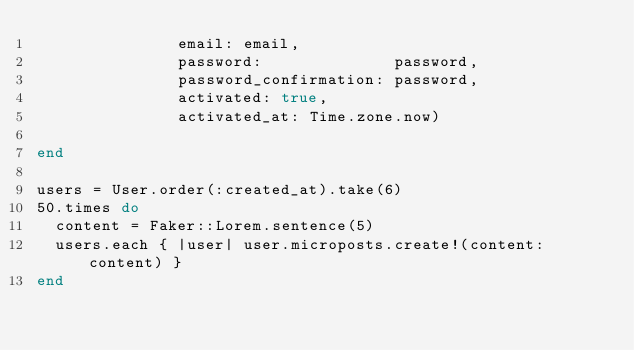<code> <loc_0><loc_0><loc_500><loc_500><_Ruby_>               email: email,
               password:              password,
               password_confirmation: password,
               activated: true,
               activated_at: Time.zone.now)
               
end

users = User.order(:created_at).take(6)
50.times do
  content = Faker::Lorem.sentence(5)
  users.each { |user| user.microposts.create!(content: content) }
end</code> 